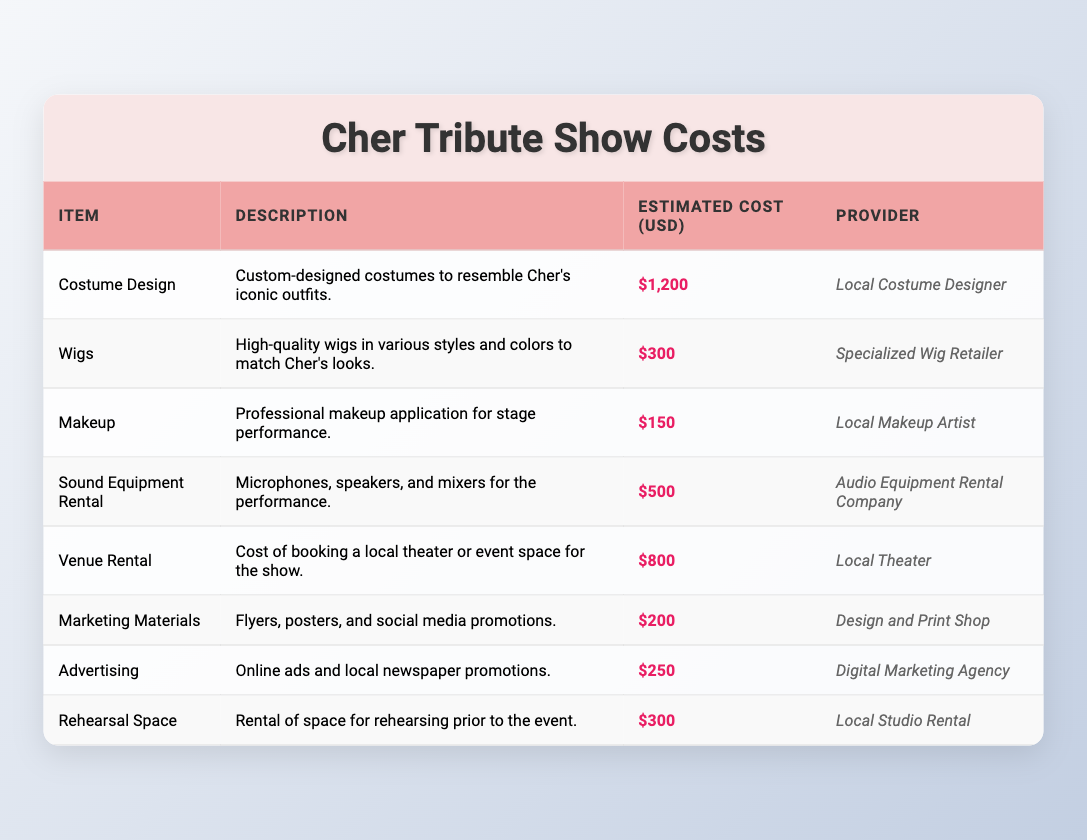What is the total estimated cost for staging a Cher tribute show? To find the total estimated cost, we need to sum the estimated costs of all items listed in the table: $1200 (Costume Design) + $300 (Wigs) + $150 (Makeup) + $500 (Sound Equipment Rental) + $800 (Venue Rental) + $200 (Marketing Materials) + $250 (Advertising) + $300 (Rehearsal Space) = $3200.
Answer: 3200 Which item has the highest estimated cost? By reviewing the Estimated Cost column, we can identify that the item with the highest estimated cost is Costume Design with $1200.
Answer: Costume Design Is the estimated cost for makeup lower than that for wigs? The estimated cost for Makeup is $150, while for Wigs it is $300. Since $150 is indeed lower than $300, the statement is true.
Answer: Yes What is the total estimated cost associated with marketing (including Marketing Materials and Advertising)? To find the total marketing costs, we add the costs associated with Marketing Materials ($200) and Advertising ($250): $200 + $250 = $450.
Answer: 450 Are all providers local businesses? Review the Provider column: Local Costume Designer, Specialized Wig Retailer, Local Makeup Artist, Audio Equipment Rental Company, Local Theater, Design and Print Shop, Digital Marketing Agency, and Local Studio Rental. Since at least one provider (Digital Marketing Agency) is not local, the statement is false.
Answer: No What is the average cost of all items listed in the table? To calculate the average cost, first sum up the estimated costs: $3200 (from the first question) and divide by the number of items (8): $3200 / 8 = $400.
Answer: 400 What is the combined cost of venue rental and sound equipment rental? The cost for Venue Rental is $800, and for Sound Equipment Rental it is $500. Adding both together gives $800 + $500 = $1300.
Answer: 1300 Is the estimated cost for rehearsal space greater than the combined cost of marketing materials and advertising? The estimated cost for Rehearsal Space is $300. The combined cost of Marketing Materials ($200) and Advertising ($250) is $450. Since $300 is not greater than $450, the statement is false.
Answer: No What is the range of estimated costs for the listed items? To find the range, we identify the highest estimated cost ($1200 for Costume Design) and the lowest estimated cost ($150 for Makeup). The range is calculated as Highest - Lowest = $1200 - $150 = $1050.
Answer: 1050 